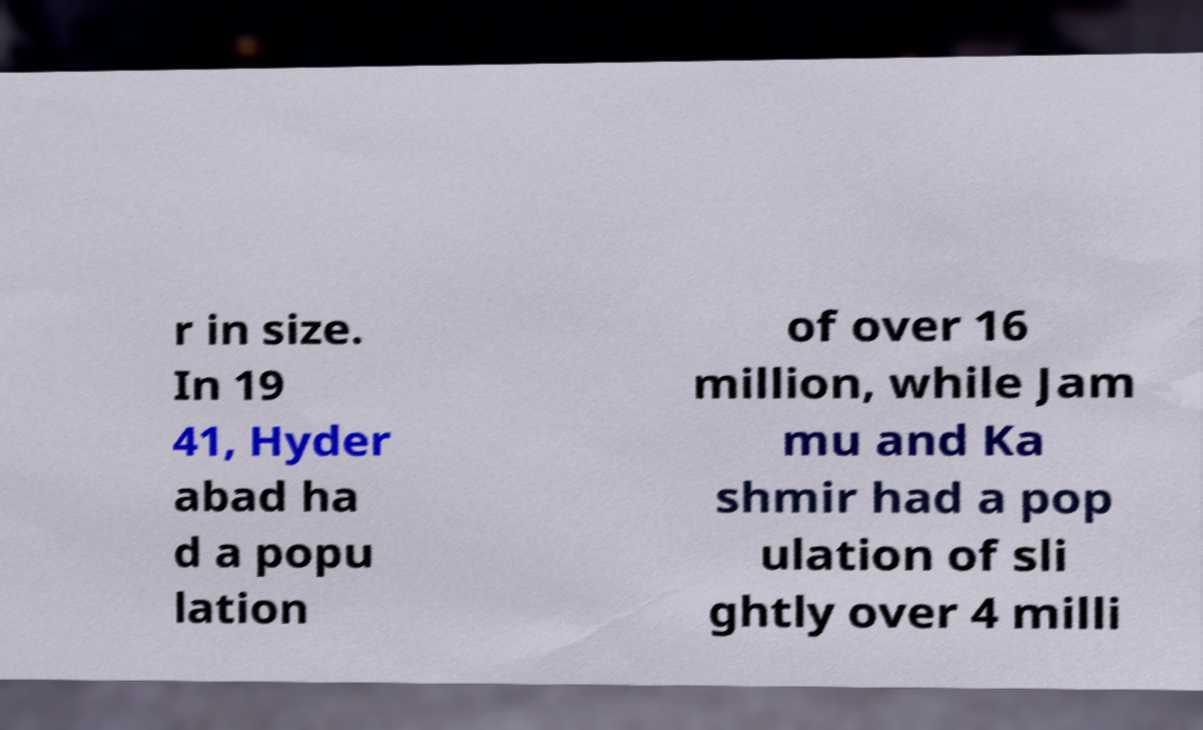What messages or text are displayed in this image? I need them in a readable, typed format. r in size. In 19 41, Hyder abad ha d a popu lation of over 16 million, while Jam mu and Ka shmir had a pop ulation of sli ghtly over 4 milli 